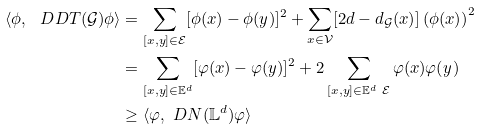Convert formula to latex. <formula><loc_0><loc_0><loc_500><loc_500>\langle \phi , \ D D T ( \mathcal { G } ) \phi \rangle & = \sum _ { [ x , y ] \in \mathcal { E } } [ \phi ( x ) - \phi ( y ) ] ^ { 2 } + \sum _ { x \in \mathcal { V } } [ 2 d - d _ { \mathcal { G } } ( x ) ] \left ( \phi ( x ) \right ) ^ { 2 } \\ & = \sum _ { [ x , y ] \in \mathbb { E } ^ { d } } [ \varphi ( x ) - \varphi ( y ) ] ^ { 2 } + 2 \sum _ { [ x , y ] \in \mathbb { E } ^ { d } \ \mathcal { E } } \varphi ( x ) \varphi ( y ) \\ & \geq \langle \varphi , \ D N ( \mathbb { L } ^ { d } ) \varphi \rangle</formula> 